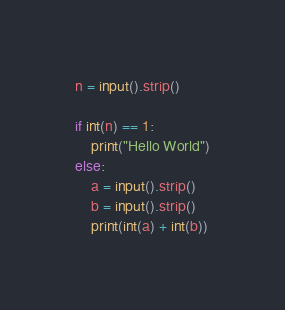<code> <loc_0><loc_0><loc_500><loc_500><_Python_>n = input().strip()

if int(n) == 1:
    print("Hello World")
else:
    a = input().strip()
    b = input().strip()
    print(int(a) + int(b))
</code> 